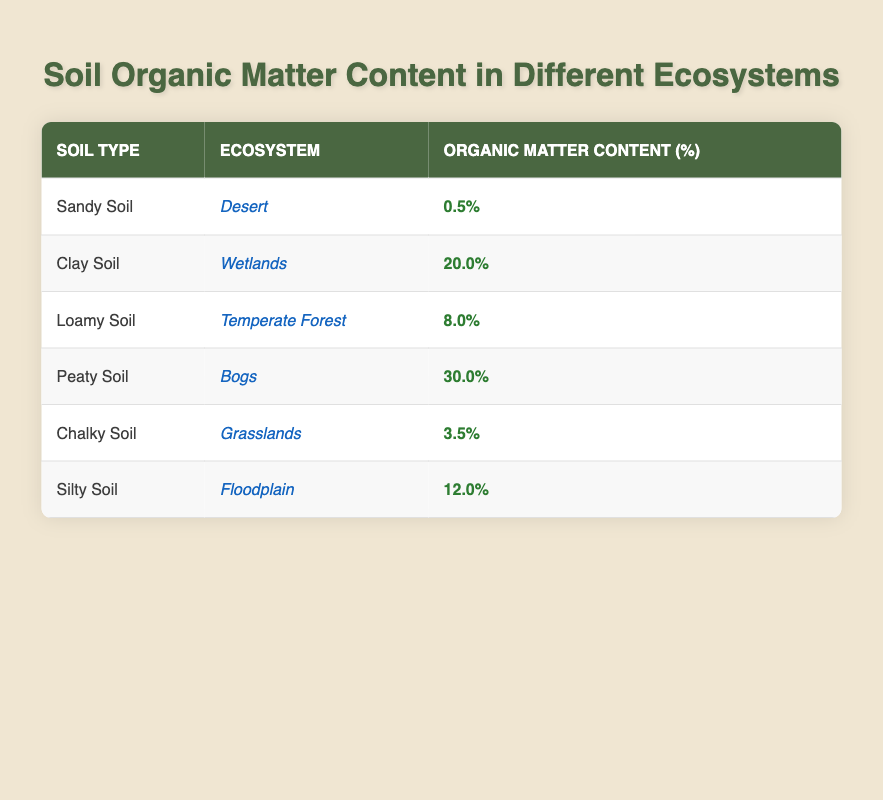What is the organic matter content of Sandy Soil? The table shows the organic matter content percentage for different soil types. For Sandy Soil, the corresponding organic matter content percentage is provided in the table. By looking at the row for Sandy Soil, the organic matter content is 0.5%.
Answer: 0.5% Which soil type has the highest organic matter content? To find the highest organic matter content, we can check the organic matter percentages for all soil types listed in the table. By comparing the percentages, Peaty Soil has the highest value at 30.0%.
Answer: Peaty Soil Is the organic matter content of Clay Soil greater than 10%? The table indicates that Clay Soil has an organic matter content of 20.0%. Since 20.0% is greater than 10%, the fact is true.
Answer: Yes What is the average organic matter content of all the soil types listed? To calculate the average, we first sum the organic matter contents: 0.5 + 20.0 + 8.0 + 30.0 + 3.5 + 12.0 = 74.0%. There are six soil types, so we divide the total by 6: 74.0% / 6 = 12.33%.
Answer: 12.33% Does the organic matter content of Silty Soil exceed that of Chalky Soil? Silty Soil has an organic matter content of 12.0% and Chalky Soil has 3.5%. By comparing these values, since 12.0% is greater than 3.5%, this statement is true.
Answer: Yes What is the difference in organic matter content between Peaty Soil and Loamy Soil? The organic matter content of Peaty Soil is 30.0% and for Loamy Soil, it is 8.0%. We find the difference by subtracting the lower value (Loamy Soil) from the higher value (Peaty Soil): 30.0% - 8.0% = 22.0%.
Answer: 22.0% Which ecosystem has the lowest organic matter content, and what is the percentage? The table must be examined for ecosystem listings and their related organic matter contents. Sandy Soil in the Desert ecosystem has an organic matter content of 0.5%, which is the lowest in the table.
Answer: Desert, 0.5% Are there any soil types with organic matter content above 15%? By reviewing the table, we note the organic matter contents for each soil type. The only soil type above 15% is Clay Soil at 20.0% and Peaty Soil at 30.0%. Therefore, the answer is yes.
Answer: Yes 